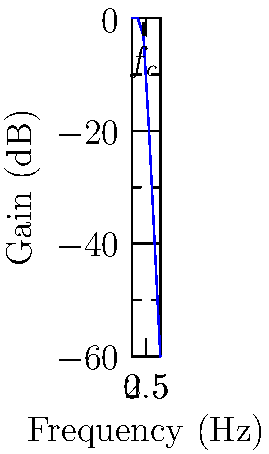You notice a circuit diagram on your neighbor's desk showing an RC low-pass filter with $R = 1.6 \text{ k}\Omega$ and $C = 100 \text{ nF}$. What is the cutoff frequency $f_c$ of this filter in Hz? To find the cutoff frequency of an RC low-pass filter:

1. The formula for cutoff frequency is:
   $f_c = \frac{1}{2\pi RC}$

2. Given values:
   $R = 1.6 \text{ k}\Omega = 1600 \Omega$
   $C = 100 \text{ nF} = 100 \times 10^{-9} \text{ F}$

3. Substitute these values into the formula:
   $f_c = \frac{1}{2\pi (1600)(100 \times 10^{-9})}$

4. Calculate:
   $f_c = \frac{1}{2\pi (1.6 \times 10^{-4})}$
   $f_c = \frac{1}{3.2\pi \times 10^{-4}}$
   $f_c \approx 995.37 \text{ Hz}$

5. Round to a reasonable precision:
   $f_c \approx 995 \text{ Hz}$
Answer: 995 Hz 